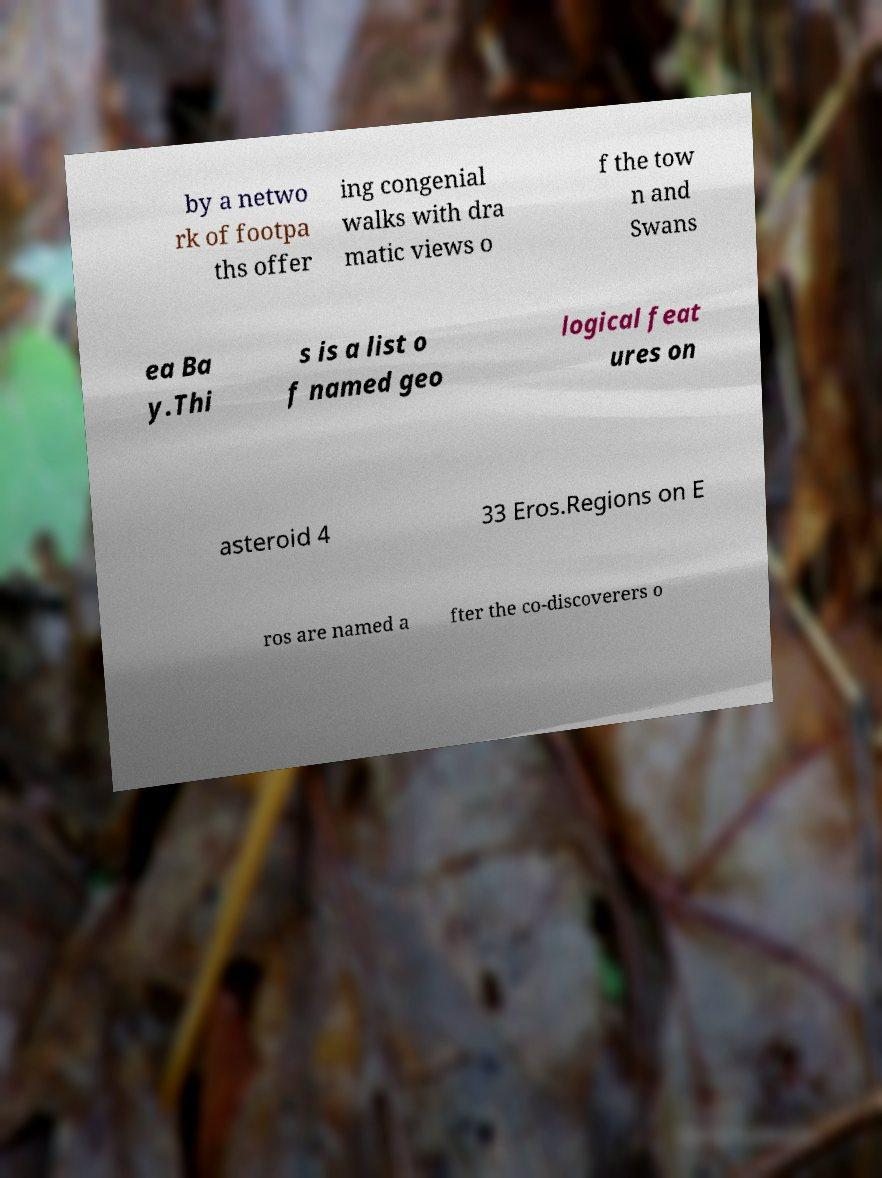What messages or text are displayed in this image? I need them in a readable, typed format. by a netwo rk of footpa ths offer ing congenial walks with dra matic views o f the tow n and Swans ea Ba y.Thi s is a list o f named geo logical feat ures on asteroid 4 33 Eros.Regions on E ros are named a fter the co-discoverers o 